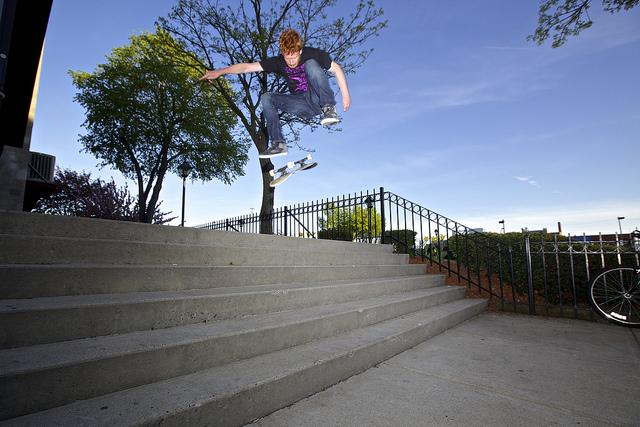If the skateboard kept this orientation how would his landing be? like it 